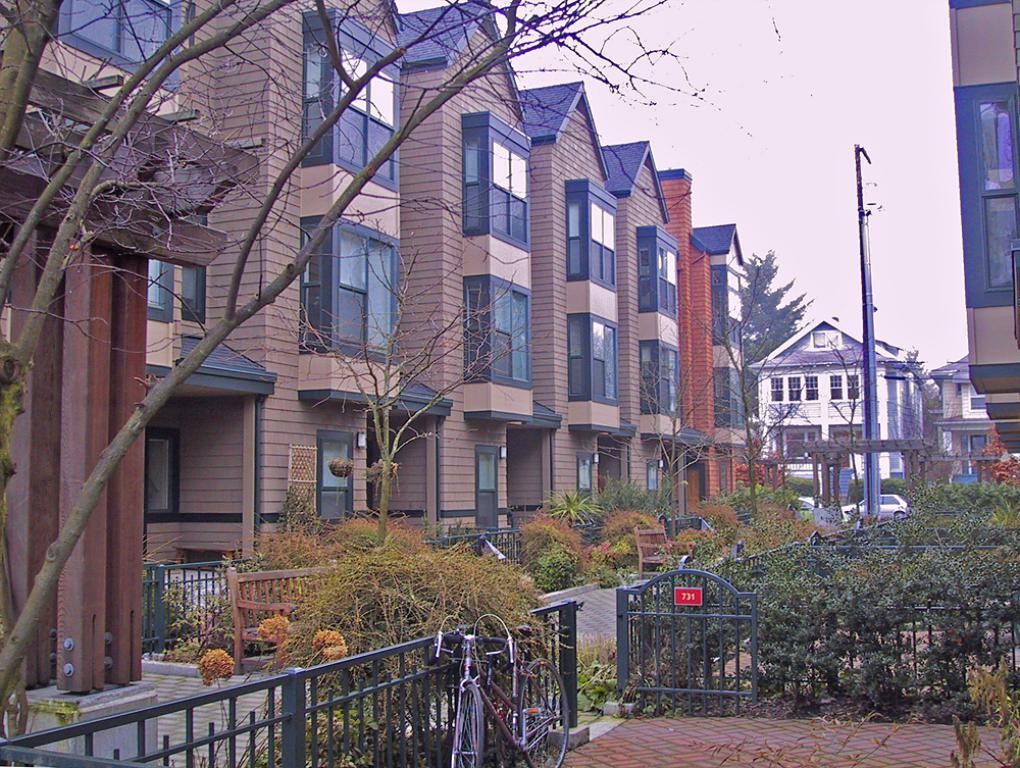Can you describe this image briefly? In this image there are plants and trees. There is a road. There are vehicles. There are buildings. There is an electric pole. There is a sky. There is fencing. 